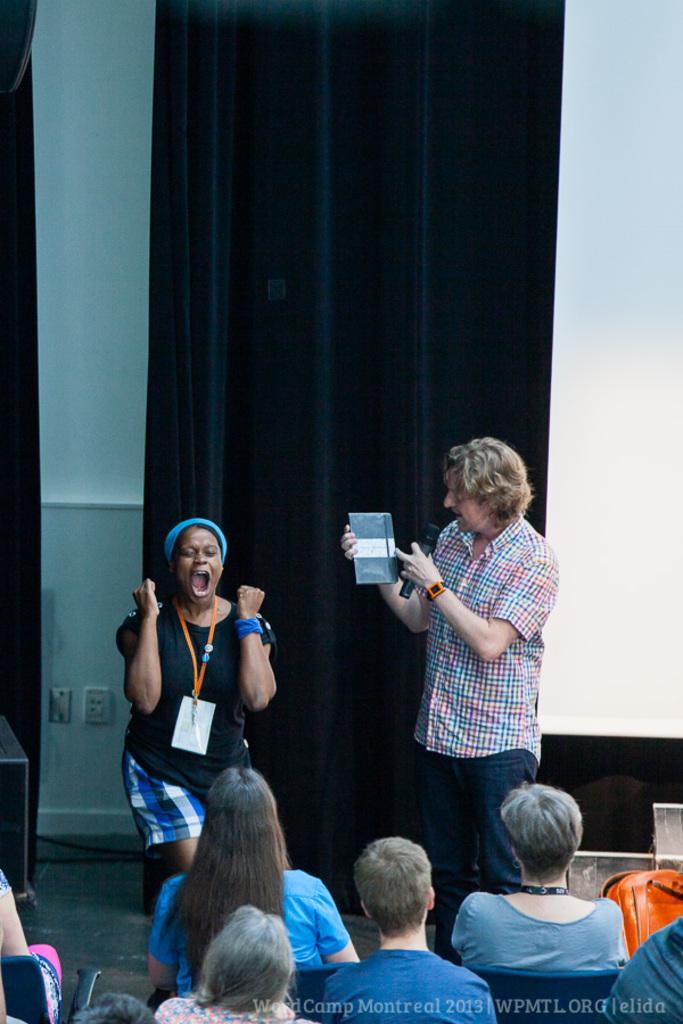Describe this image in one or two sentences. On the bottom right, there is a watermark. In the background, there are persons sitting. In front of them, there is a woman exciting on a stage. Beside her, there is a person holding an object with one hand, holding a mix with other hand and standing. In the background, there is a curtain and there is a white wall. 